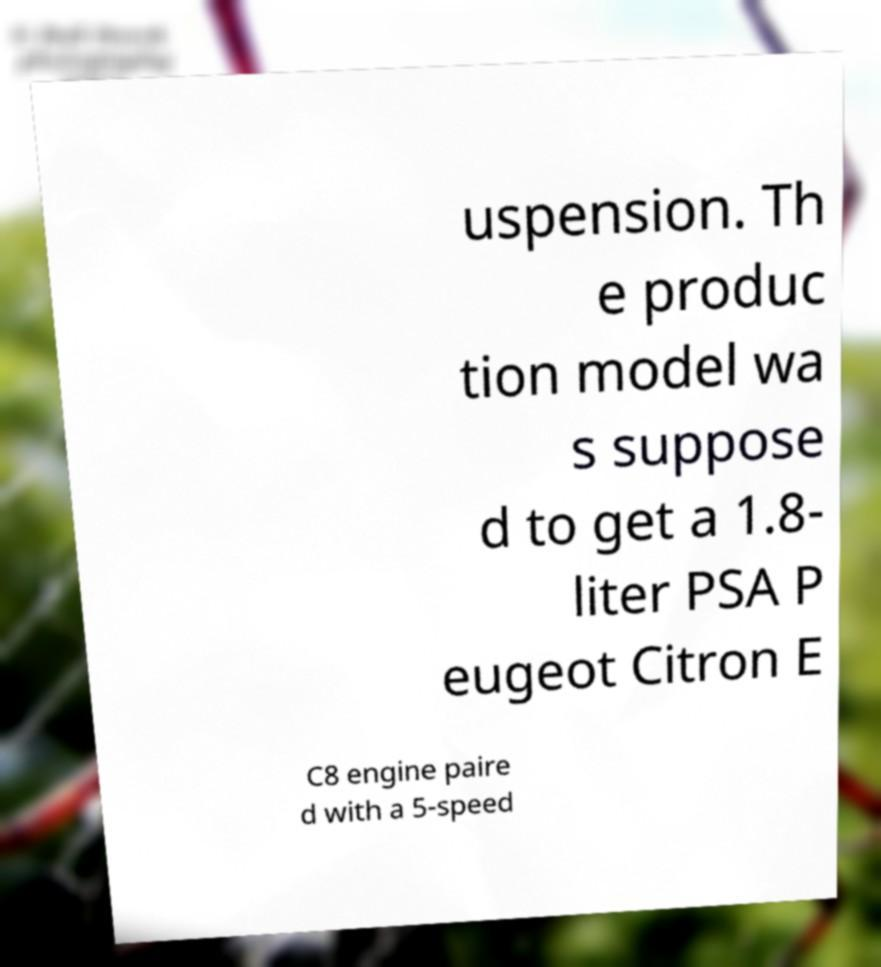Can you accurately transcribe the text from the provided image for me? uspension. Th e produc tion model wa s suppose d to get a 1.8- liter PSA P eugeot Citron E C8 engine paire d with a 5-speed 